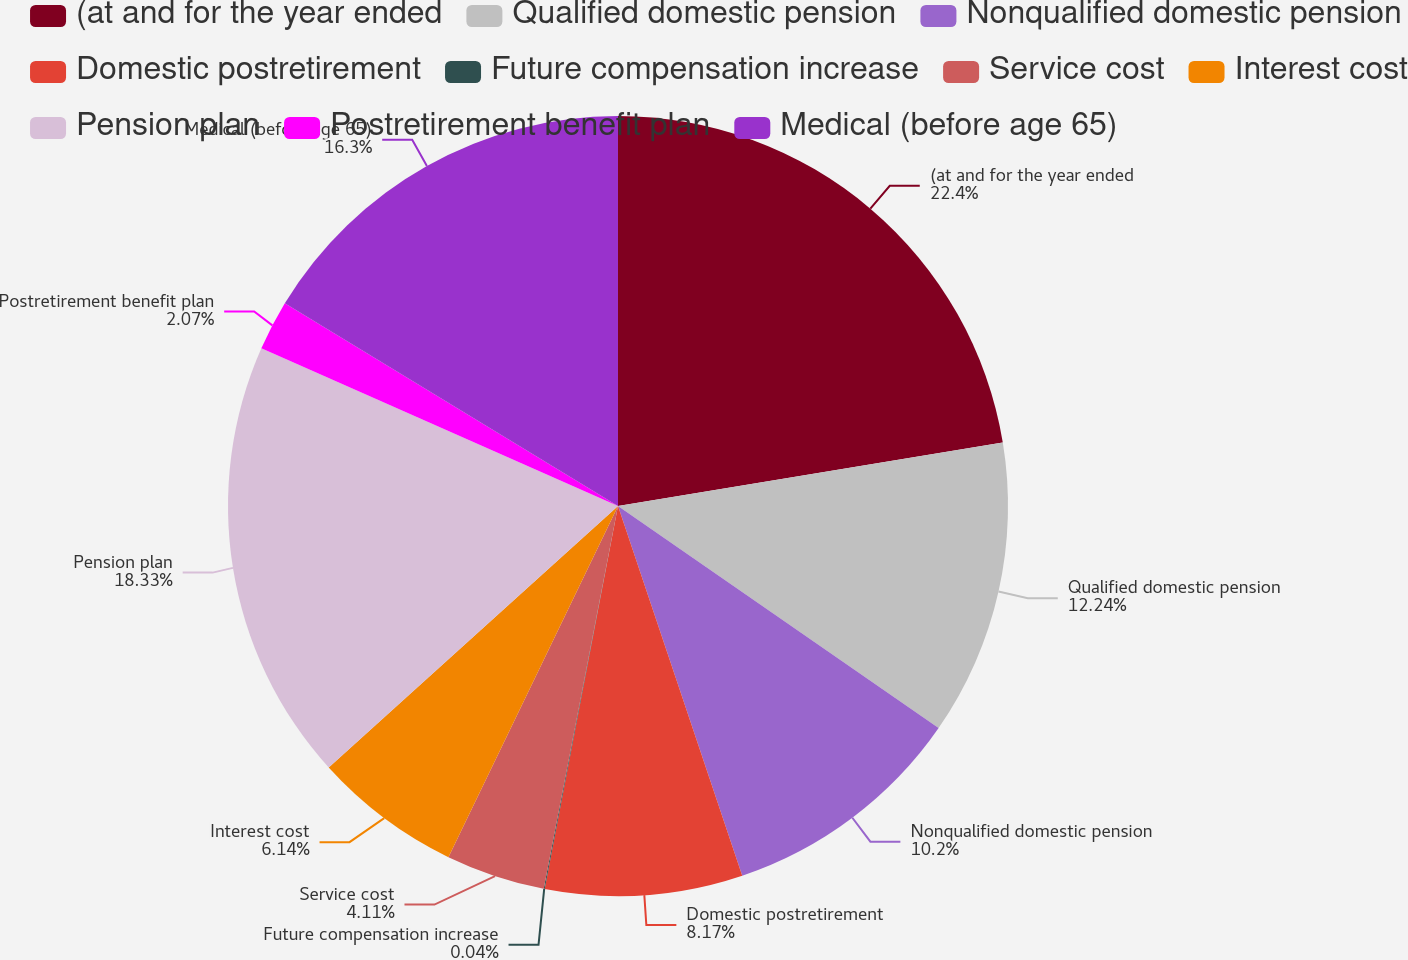<chart> <loc_0><loc_0><loc_500><loc_500><pie_chart><fcel>(at and for the year ended<fcel>Qualified domestic pension<fcel>Nonqualified domestic pension<fcel>Domestic postretirement<fcel>Future compensation increase<fcel>Service cost<fcel>Interest cost<fcel>Pension plan<fcel>Postretirement benefit plan<fcel>Medical (before age 65)<nl><fcel>22.4%<fcel>12.24%<fcel>10.2%<fcel>8.17%<fcel>0.04%<fcel>4.11%<fcel>6.14%<fcel>18.33%<fcel>2.07%<fcel>16.3%<nl></chart> 